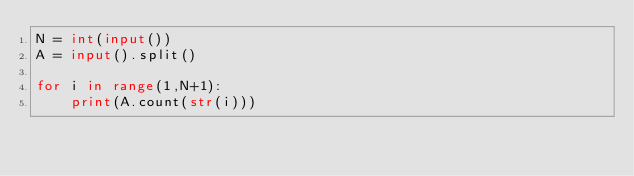Convert code to text. <code><loc_0><loc_0><loc_500><loc_500><_Python_>N = int(input())
A = input().split()

for i in range(1,N+1):
    print(A.count(str(i)))
</code> 